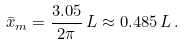Convert formula to latex. <formula><loc_0><loc_0><loc_500><loc_500>\bar { x } _ { m } = \frac { 3 . 0 5 } { 2 \pi } \, L \approx 0 . 4 8 5 \, L \, .</formula> 